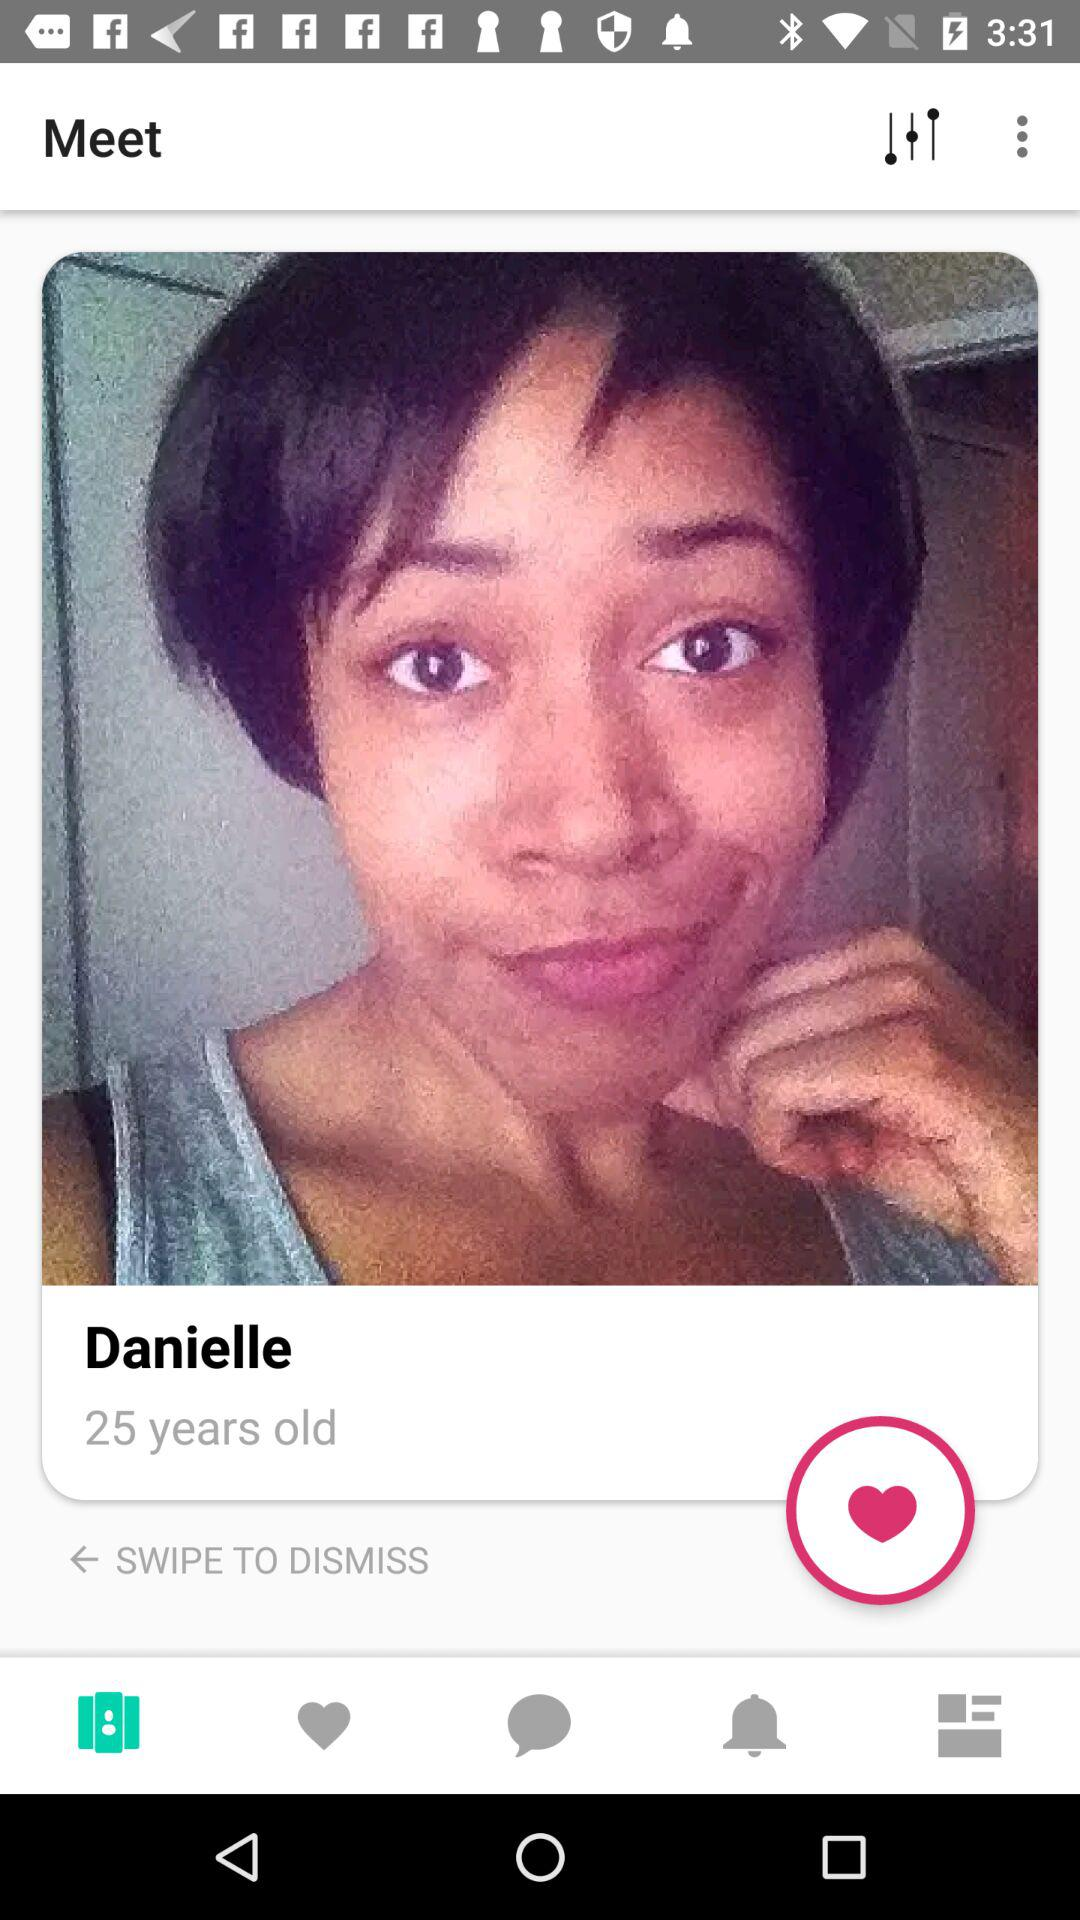How many more hearts are there than arrows?
Answer the question using a single word or phrase. 1 